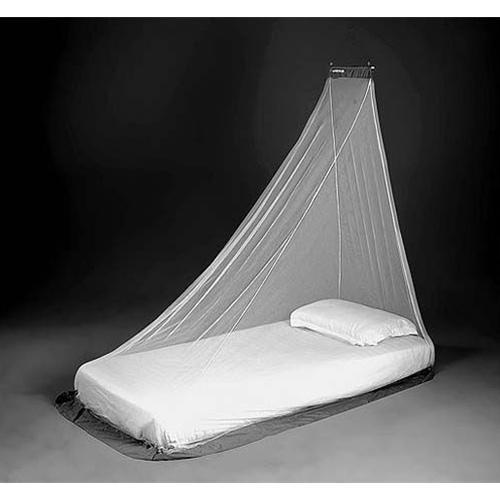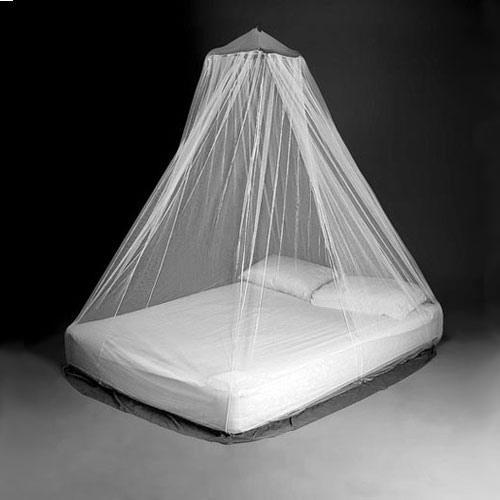The first image is the image on the left, the second image is the image on the right. Examine the images to the left and right. Is the description "Two or more pillows are visible." accurate? Answer yes or no. Yes. The first image is the image on the left, the second image is the image on the right. Assess this claim about the two images: "There are two pillows in the right image.". Correct or not? Answer yes or no. Yes. 